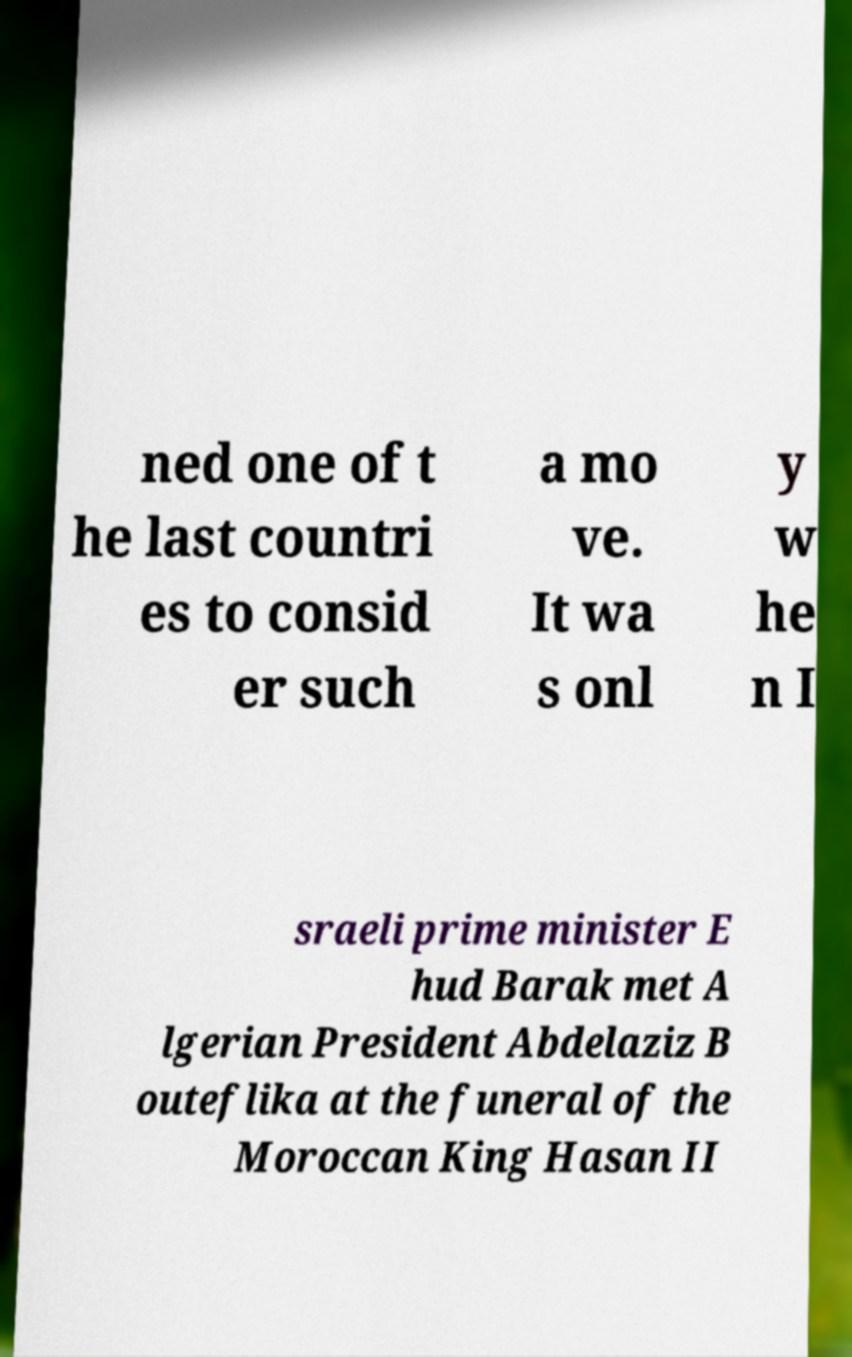Can you read and provide the text displayed in the image?This photo seems to have some interesting text. Can you extract and type it out for me? ned one of t he last countri es to consid er such a mo ve. It wa s onl y w he n I sraeli prime minister E hud Barak met A lgerian President Abdelaziz B outeflika at the funeral of the Moroccan King Hasan II 